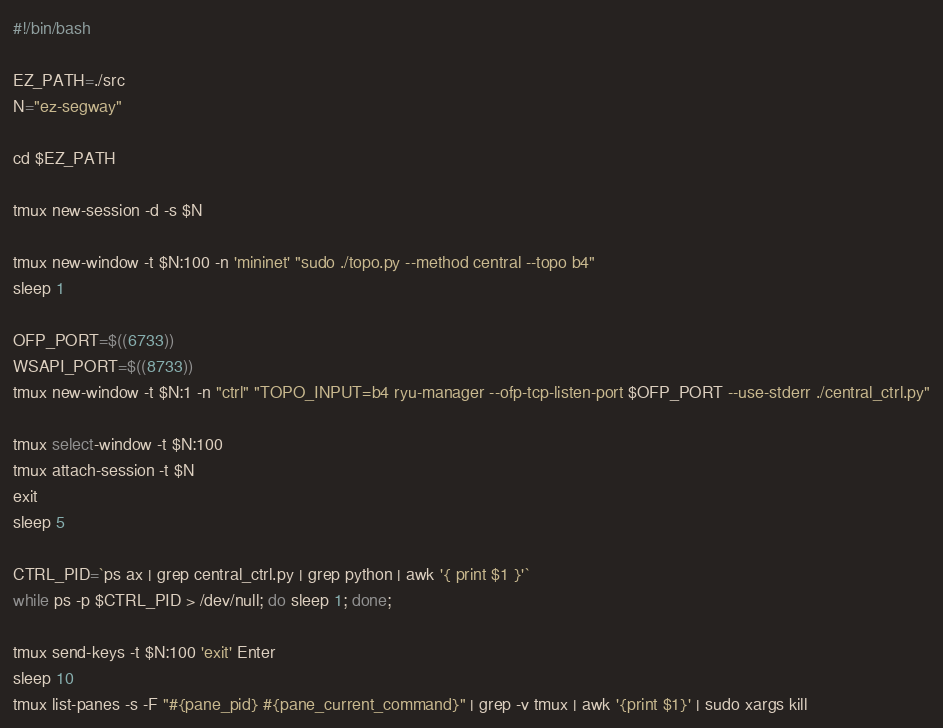<code> <loc_0><loc_0><loc_500><loc_500><_Bash_>#!/bin/bash

EZ_PATH=./src
N="ez-segway"

cd $EZ_PATH

tmux new-session -d -s $N

tmux new-window -t $N:100 -n 'mininet' "sudo ./topo.py --method central --topo b4"
sleep 1

OFP_PORT=$((6733))
WSAPI_PORT=$((8733))
tmux new-window -t $N:1 -n "ctrl" "TOPO_INPUT=b4 ryu-manager --ofp-tcp-listen-port $OFP_PORT --use-stderr ./central_ctrl.py"

tmux select-window -t $N:100
tmux attach-session -t $N
exit
sleep 5

CTRL_PID=`ps ax | grep central_ctrl.py | grep python | awk '{ print $1 }'`
while ps -p $CTRL_PID > /dev/null; do sleep 1; done;

tmux send-keys -t $N:100 'exit' Enter
sleep 10
tmux list-panes -s -F "#{pane_pid} #{pane_current_command}" | grep -v tmux | awk '{print $1}' | sudo xargs kill


</code> 